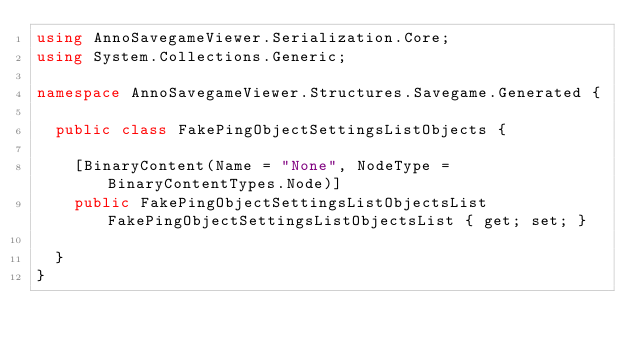Convert code to text. <code><loc_0><loc_0><loc_500><loc_500><_C#_>using AnnoSavegameViewer.Serialization.Core;
using System.Collections.Generic;

namespace AnnoSavegameViewer.Structures.Savegame.Generated {

  public class FakePingObjectSettingsListObjects {

    [BinaryContent(Name = "None", NodeType = BinaryContentTypes.Node)]
    public FakePingObjectSettingsListObjectsList FakePingObjectSettingsListObjectsList { get; set; }

  }
}</code> 